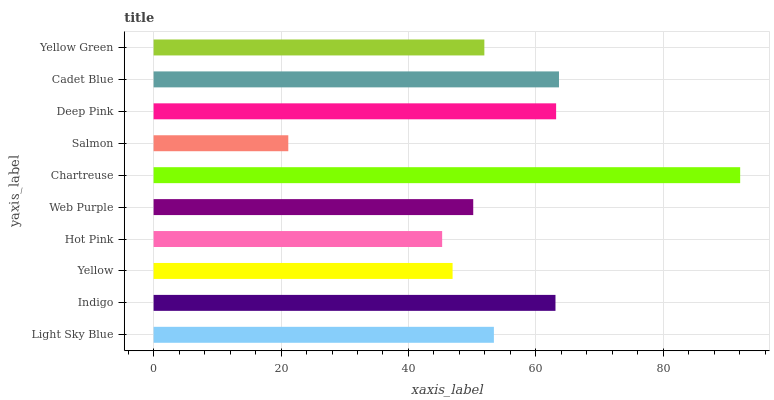Is Salmon the minimum?
Answer yes or no. Yes. Is Chartreuse the maximum?
Answer yes or no. Yes. Is Indigo the minimum?
Answer yes or no. No. Is Indigo the maximum?
Answer yes or no. No. Is Indigo greater than Light Sky Blue?
Answer yes or no. Yes. Is Light Sky Blue less than Indigo?
Answer yes or no. Yes. Is Light Sky Blue greater than Indigo?
Answer yes or no. No. Is Indigo less than Light Sky Blue?
Answer yes or no. No. Is Light Sky Blue the high median?
Answer yes or no. Yes. Is Yellow Green the low median?
Answer yes or no. Yes. Is Cadet Blue the high median?
Answer yes or no. No. Is Indigo the low median?
Answer yes or no. No. 